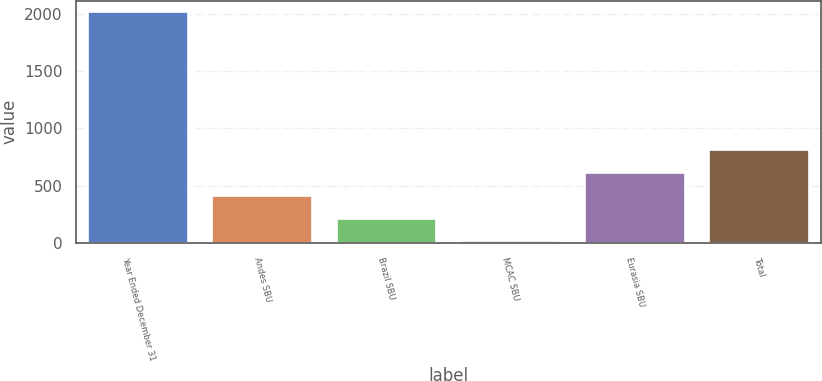Convert chart. <chart><loc_0><loc_0><loc_500><loc_500><bar_chart><fcel>Year Ended December 31<fcel>Andes SBU<fcel>Brazil SBU<fcel>MCAC SBU<fcel>Eurasia SBU<fcel>Total<nl><fcel>2016<fcel>412<fcel>211.5<fcel>11<fcel>612.5<fcel>813<nl></chart> 